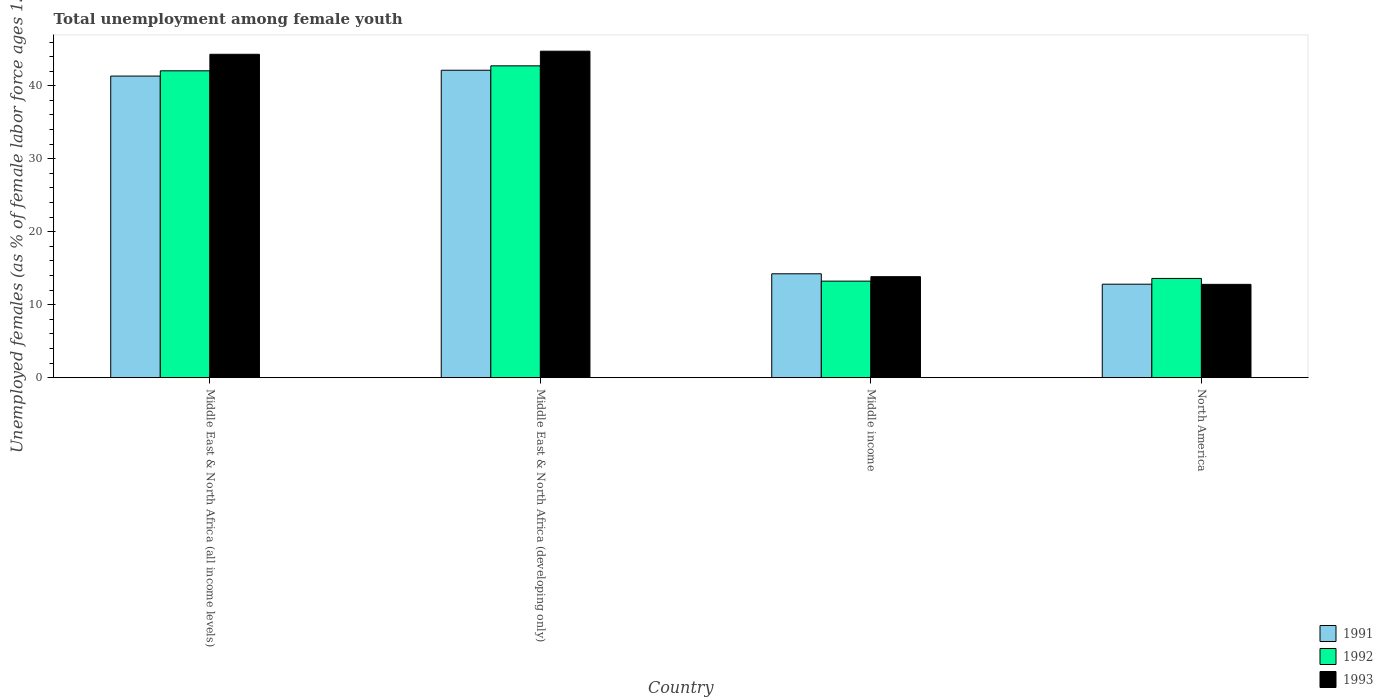Are the number of bars per tick equal to the number of legend labels?
Make the answer very short. Yes. Are the number of bars on each tick of the X-axis equal?
Give a very brief answer. Yes. What is the label of the 2nd group of bars from the left?
Make the answer very short. Middle East & North Africa (developing only). What is the percentage of unemployed females in in 1992 in Middle income?
Your response must be concise. 13.23. Across all countries, what is the maximum percentage of unemployed females in in 1993?
Offer a very short reply. 44.74. Across all countries, what is the minimum percentage of unemployed females in in 1992?
Provide a succinct answer. 13.23. In which country was the percentage of unemployed females in in 1992 maximum?
Provide a succinct answer. Middle East & North Africa (developing only). What is the total percentage of unemployed females in in 1993 in the graph?
Provide a succinct answer. 115.69. What is the difference between the percentage of unemployed females in in 1993 in Middle East & North Africa (all income levels) and that in North America?
Make the answer very short. 31.53. What is the difference between the percentage of unemployed females in in 1993 in Middle East & North Africa (developing only) and the percentage of unemployed females in in 1991 in Middle income?
Provide a succinct answer. 30.51. What is the average percentage of unemployed females in in 1992 per country?
Offer a very short reply. 27.9. What is the difference between the percentage of unemployed females in of/in 1991 and percentage of unemployed females in of/in 1992 in Middle income?
Your answer should be very brief. 1.01. What is the ratio of the percentage of unemployed females in in 1993 in Middle East & North Africa (all income levels) to that in Middle East & North Africa (developing only)?
Keep it short and to the point. 0.99. Is the percentage of unemployed females in in 1991 in Middle East & North Africa (all income levels) less than that in North America?
Provide a short and direct response. No. Is the difference between the percentage of unemployed females in in 1991 in Middle East & North Africa (developing only) and Middle income greater than the difference between the percentage of unemployed females in in 1992 in Middle East & North Africa (developing only) and Middle income?
Give a very brief answer. No. What is the difference between the highest and the second highest percentage of unemployed females in in 1993?
Your response must be concise. 30.9. What is the difference between the highest and the lowest percentage of unemployed females in in 1992?
Make the answer very short. 29.51. Is the sum of the percentage of unemployed females in in 1993 in Middle East & North Africa (all income levels) and Middle income greater than the maximum percentage of unemployed females in in 1991 across all countries?
Ensure brevity in your answer.  Yes. What does the 2nd bar from the right in North America represents?
Offer a very short reply. 1992. Is it the case that in every country, the sum of the percentage of unemployed females in in 1992 and percentage of unemployed females in in 1991 is greater than the percentage of unemployed females in in 1993?
Provide a succinct answer. Yes. How many bars are there?
Provide a short and direct response. 12. Are all the bars in the graph horizontal?
Your answer should be very brief. No. What is the difference between two consecutive major ticks on the Y-axis?
Offer a terse response. 10. Are the values on the major ticks of Y-axis written in scientific E-notation?
Ensure brevity in your answer.  No. Does the graph contain any zero values?
Offer a very short reply. No. Does the graph contain grids?
Give a very brief answer. No. Where does the legend appear in the graph?
Offer a very short reply. Bottom right. How are the legend labels stacked?
Offer a very short reply. Vertical. What is the title of the graph?
Your answer should be compact. Total unemployment among female youth. What is the label or title of the X-axis?
Keep it short and to the point. Country. What is the label or title of the Y-axis?
Keep it short and to the point. Unemployed females (as % of female labor force ages 15-24). What is the Unemployed females (as % of female labor force ages 15-24) of 1991 in Middle East & North Africa (all income levels)?
Your answer should be compact. 41.33. What is the Unemployed females (as % of female labor force ages 15-24) in 1992 in Middle East & North Africa (all income levels)?
Make the answer very short. 42.05. What is the Unemployed females (as % of female labor force ages 15-24) of 1993 in Middle East & North Africa (all income levels)?
Make the answer very short. 44.32. What is the Unemployed females (as % of female labor force ages 15-24) of 1991 in Middle East & North Africa (developing only)?
Make the answer very short. 42.13. What is the Unemployed females (as % of female labor force ages 15-24) in 1992 in Middle East & North Africa (developing only)?
Your response must be concise. 42.73. What is the Unemployed females (as % of female labor force ages 15-24) of 1993 in Middle East & North Africa (developing only)?
Give a very brief answer. 44.74. What is the Unemployed females (as % of female labor force ages 15-24) in 1991 in Middle income?
Make the answer very short. 14.24. What is the Unemployed females (as % of female labor force ages 15-24) in 1992 in Middle income?
Keep it short and to the point. 13.23. What is the Unemployed females (as % of female labor force ages 15-24) in 1993 in Middle income?
Your response must be concise. 13.84. What is the Unemployed females (as % of female labor force ages 15-24) of 1991 in North America?
Keep it short and to the point. 12.81. What is the Unemployed females (as % of female labor force ages 15-24) in 1992 in North America?
Your answer should be compact. 13.6. What is the Unemployed females (as % of female labor force ages 15-24) in 1993 in North America?
Give a very brief answer. 12.79. Across all countries, what is the maximum Unemployed females (as % of female labor force ages 15-24) of 1991?
Provide a short and direct response. 42.13. Across all countries, what is the maximum Unemployed females (as % of female labor force ages 15-24) of 1992?
Your answer should be compact. 42.73. Across all countries, what is the maximum Unemployed females (as % of female labor force ages 15-24) in 1993?
Offer a very short reply. 44.74. Across all countries, what is the minimum Unemployed females (as % of female labor force ages 15-24) of 1991?
Your answer should be very brief. 12.81. Across all countries, what is the minimum Unemployed females (as % of female labor force ages 15-24) of 1992?
Ensure brevity in your answer.  13.23. Across all countries, what is the minimum Unemployed females (as % of female labor force ages 15-24) in 1993?
Offer a very short reply. 12.79. What is the total Unemployed females (as % of female labor force ages 15-24) in 1991 in the graph?
Give a very brief answer. 110.51. What is the total Unemployed females (as % of female labor force ages 15-24) in 1992 in the graph?
Offer a very short reply. 111.62. What is the total Unemployed females (as % of female labor force ages 15-24) in 1993 in the graph?
Offer a very short reply. 115.69. What is the difference between the Unemployed females (as % of female labor force ages 15-24) in 1991 in Middle East & North Africa (all income levels) and that in Middle East & North Africa (developing only)?
Offer a terse response. -0.8. What is the difference between the Unemployed females (as % of female labor force ages 15-24) in 1992 in Middle East & North Africa (all income levels) and that in Middle East & North Africa (developing only)?
Your answer should be very brief. -0.68. What is the difference between the Unemployed females (as % of female labor force ages 15-24) of 1993 in Middle East & North Africa (all income levels) and that in Middle East & North Africa (developing only)?
Your answer should be very brief. -0.42. What is the difference between the Unemployed females (as % of female labor force ages 15-24) in 1991 in Middle East & North Africa (all income levels) and that in Middle income?
Your answer should be compact. 27.1. What is the difference between the Unemployed females (as % of female labor force ages 15-24) of 1992 in Middle East & North Africa (all income levels) and that in Middle income?
Make the answer very short. 28.83. What is the difference between the Unemployed females (as % of female labor force ages 15-24) in 1993 in Middle East & North Africa (all income levels) and that in Middle income?
Offer a very short reply. 30.48. What is the difference between the Unemployed females (as % of female labor force ages 15-24) in 1991 in Middle East & North Africa (all income levels) and that in North America?
Ensure brevity in your answer.  28.52. What is the difference between the Unemployed females (as % of female labor force ages 15-24) in 1992 in Middle East & North Africa (all income levels) and that in North America?
Keep it short and to the point. 28.46. What is the difference between the Unemployed females (as % of female labor force ages 15-24) in 1993 in Middle East & North Africa (all income levels) and that in North America?
Provide a succinct answer. 31.53. What is the difference between the Unemployed females (as % of female labor force ages 15-24) of 1991 in Middle East & North Africa (developing only) and that in Middle income?
Provide a short and direct response. 27.9. What is the difference between the Unemployed females (as % of female labor force ages 15-24) of 1992 in Middle East & North Africa (developing only) and that in Middle income?
Keep it short and to the point. 29.51. What is the difference between the Unemployed females (as % of female labor force ages 15-24) of 1993 in Middle East & North Africa (developing only) and that in Middle income?
Provide a succinct answer. 30.9. What is the difference between the Unemployed females (as % of female labor force ages 15-24) of 1991 in Middle East & North Africa (developing only) and that in North America?
Offer a terse response. 29.32. What is the difference between the Unemployed females (as % of female labor force ages 15-24) in 1992 in Middle East & North Africa (developing only) and that in North America?
Give a very brief answer. 29.13. What is the difference between the Unemployed females (as % of female labor force ages 15-24) in 1993 in Middle East & North Africa (developing only) and that in North America?
Offer a terse response. 31.95. What is the difference between the Unemployed females (as % of female labor force ages 15-24) of 1991 in Middle income and that in North America?
Your answer should be compact. 1.43. What is the difference between the Unemployed females (as % of female labor force ages 15-24) of 1992 in Middle income and that in North America?
Provide a short and direct response. -0.37. What is the difference between the Unemployed females (as % of female labor force ages 15-24) in 1993 in Middle income and that in North America?
Provide a succinct answer. 1.05. What is the difference between the Unemployed females (as % of female labor force ages 15-24) of 1991 in Middle East & North Africa (all income levels) and the Unemployed females (as % of female labor force ages 15-24) of 1992 in Middle East & North Africa (developing only)?
Your answer should be very brief. -1.4. What is the difference between the Unemployed females (as % of female labor force ages 15-24) in 1991 in Middle East & North Africa (all income levels) and the Unemployed females (as % of female labor force ages 15-24) in 1993 in Middle East & North Africa (developing only)?
Keep it short and to the point. -3.41. What is the difference between the Unemployed females (as % of female labor force ages 15-24) in 1992 in Middle East & North Africa (all income levels) and the Unemployed females (as % of female labor force ages 15-24) in 1993 in Middle East & North Africa (developing only)?
Your answer should be very brief. -2.69. What is the difference between the Unemployed females (as % of female labor force ages 15-24) in 1991 in Middle East & North Africa (all income levels) and the Unemployed females (as % of female labor force ages 15-24) in 1992 in Middle income?
Offer a terse response. 28.1. What is the difference between the Unemployed females (as % of female labor force ages 15-24) of 1991 in Middle East & North Africa (all income levels) and the Unemployed females (as % of female labor force ages 15-24) of 1993 in Middle income?
Provide a succinct answer. 27.49. What is the difference between the Unemployed females (as % of female labor force ages 15-24) of 1992 in Middle East & North Africa (all income levels) and the Unemployed females (as % of female labor force ages 15-24) of 1993 in Middle income?
Ensure brevity in your answer.  28.21. What is the difference between the Unemployed females (as % of female labor force ages 15-24) in 1991 in Middle East & North Africa (all income levels) and the Unemployed females (as % of female labor force ages 15-24) in 1992 in North America?
Offer a very short reply. 27.73. What is the difference between the Unemployed females (as % of female labor force ages 15-24) in 1991 in Middle East & North Africa (all income levels) and the Unemployed females (as % of female labor force ages 15-24) in 1993 in North America?
Your answer should be very brief. 28.54. What is the difference between the Unemployed females (as % of female labor force ages 15-24) of 1992 in Middle East & North Africa (all income levels) and the Unemployed females (as % of female labor force ages 15-24) of 1993 in North America?
Offer a very short reply. 29.27. What is the difference between the Unemployed females (as % of female labor force ages 15-24) of 1991 in Middle East & North Africa (developing only) and the Unemployed females (as % of female labor force ages 15-24) of 1992 in Middle income?
Your answer should be very brief. 28.9. What is the difference between the Unemployed females (as % of female labor force ages 15-24) in 1991 in Middle East & North Africa (developing only) and the Unemployed females (as % of female labor force ages 15-24) in 1993 in Middle income?
Give a very brief answer. 28.29. What is the difference between the Unemployed females (as % of female labor force ages 15-24) of 1992 in Middle East & North Africa (developing only) and the Unemployed females (as % of female labor force ages 15-24) of 1993 in Middle income?
Provide a succinct answer. 28.89. What is the difference between the Unemployed females (as % of female labor force ages 15-24) in 1991 in Middle East & North Africa (developing only) and the Unemployed females (as % of female labor force ages 15-24) in 1992 in North America?
Your answer should be very brief. 28.53. What is the difference between the Unemployed females (as % of female labor force ages 15-24) of 1991 in Middle East & North Africa (developing only) and the Unemployed females (as % of female labor force ages 15-24) of 1993 in North America?
Your response must be concise. 29.34. What is the difference between the Unemployed females (as % of female labor force ages 15-24) of 1992 in Middle East & North Africa (developing only) and the Unemployed females (as % of female labor force ages 15-24) of 1993 in North America?
Offer a terse response. 29.95. What is the difference between the Unemployed females (as % of female labor force ages 15-24) in 1991 in Middle income and the Unemployed females (as % of female labor force ages 15-24) in 1992 in North America?
Your response must be concise. 0.64. What is the difference between the Unemployed females (as % of female labor force ages 15-24) in 1991 in Middle income and the Unemployed females (as % of female labor force ages 15-24) in 1993 in North America?
Offer a very short reply. 1.45. What is the difference between the Unemployed females (as % of female labor force ages 15-24) of 1992 in Middle income and the Unemployed females (as % of female labor force ages 15-24) of 1993 in North America?
Offer a terse response. 0.44. What is the average Unemployed females (as % of female labor force ages 15-24) of 1991 per country?
Provide a succinct answer. 27.63. What is the average Unemployed females (as % of female labor force ages 15-24) in 1992 per country?
Offer a very short reply. 27.9. What is the average Unemployed females (as % of female labor force ages 15-24) of 1993 per country?
Your answer should be compact. 28.92. What is the difference between the Unemployed females (as % of female labor force ages 15-24) in 1991 and Unemployed females (as % of female labor force ages 15-24) in 1992 in Middle East & North Africa (all income levels)?
Provide a short and direct response. -0.72. What is the difference between the Unemployed females (as % of female labor force ages 15-24) of 1991 and Unemployed females (as % of female labor force ages 15-24) of 1993 in Middle East & North Africa (all income levels)?
Keep it short and to the point. -2.99. What is the difference between the Unemployed females (as % of female labor force ages 15-24) in 1992 and Unemployed females (as % of female labor force ages 15-24) in 1993 in Middle East & North Africa (all income levels)?
Provide a succinct answer. -2.26. What is the difference between the Unemployed females (as % of female labor force ages 15-24) of 1991 and Unemployed females (as % of female labor force ages 15-24) of 1992 in Middle East & North Africa (developing only)?
Provide a short and direct response. -0.6. What is the difference between the Unemployed females (as % of female labor force ages 15-24) in 1991 and Unemployed females (as % of female labor force ages 15-24) in 1993 in Middle East & North Africa (developing only)?
Provide a succinct answer. -2.61. What is the difference between the Unemployed females (as % of female labor force ages 15-24) of 1992 and Unemployed females (as % of female labor force ages 15-24) of 1993 in Middle East & North Africa (developing only)?
Keep it short and to the point. -2.01. What is the difference between the Unemployed females (as % of female labor force ages 15-24) in 1991 and Unemployed females (as % of female labor force ages 15-24) in 1992 in Middle income?
Give a very brief answer. 1.01. What is the difference between the Unemployed females (as % of female labor force ages 15-24) in 1991 and Unemployed females (as % of female labor force ages 15-24) in 1993 in Middle income?
Offer a terse response. 0.4. What is the difference between the Unemployed females (as % of female labor force ages 15-24) of 1992 and Unemployed females (as % of female labor force ages 15-24) of 1993 in Middle income?
Your response must be concise. -0.61. What is the difference between the Unemployed females (as % of female labor force ages 15-24) of 1991 and Unemployed females (as % of female labor force ages 15-24) of 1992 in North America?
Your answer should be compact. -0.79. What is the difference between the Unemployed females (as % of female labor force ages 15-24) in 1991 and Unemployed females (as % of female labor force ages 15-24) in 1993 in North America?
Your answer should be compact. 0.02. What is the difference between the Unemployed females (as % of female labor force ages 15-24) of 1992 and Unemployed females (as % of female labor force ages 15-24) of 1993 in North America?
Your response must be concise. 0.81. What is the ratio of the Unemployed females (as % of female labor force ages 15-24) in 1991 in Middle East & North Africa (all income levels) to that in Middle East & North Africa (developing only)?
Keep it short and to the point. 0.98. What is the ratio of the Unemployed females (as % of female labor force ages 15-24) in 1992 in Middle East & North Africa (all income levels) to that in Middle East & North Africa (developing only)?
Your answer should be very brief. 0.98. What is the ratio of the Unemployed females (as % of female labor force ages 15-24) in 1993 in Middle East & North Africa (all income levels) to that in Middle East & North Africa (developing only)?
Provide a short and direct response. 0.99. What is the ratio of the Unemployed females (as % of female labor force ages 15-24) of 1991 in Middle East & North Africa (all income levels) to that in Middle income?
Provide a succinct answer. 2.9. What is the ratio of the Unemployed females (as % of female labor force ages 15-24) of 1992 in Middle East & North Africa (all income levels) to that in Middle income?
Make the answer very short. 3.18. What is the ratio of the Unemployed females (as % of female labor force ages 15-24) in 1993 in Middle East & North Africa (all income levels) to that in Middle income?
Your answer should be very brief. 3.2. What is the ratio of the Unemployed females (as % of female labor force ages 15-24) of 1991 in Middle East & North Africa (all income levels) to that in North America?
Offer a terse response. 3.23. What is the ratio of the Unemployed females (as % of female labor force ages 15-24) of 1992 in Middle East & North Africa (all income levels) to that in North America?
Provide a short and direct response. 3.09. What is the ratio of the Unemployed females (as % of female labor force ages 15-24) in 1993 in Middle East & North Africa (all income levels) to that in North America?
Provide a succinct answer. 3.47. What is the ratio of the Unemployed females (as % of female labor force ages 15-24) of 1991 in Middle East & North Africa (developing only) to that in Middle income?
Provide a succinct answer. 2.96. What is the ratio of the Unemployed females (as % of female labor force ages 15-24) in 1992 in Middle East & North Africa (developing only) to that in Middle income?
Offer a terse response. 3.23. What is the ratio of the Unemployed females (as % of female labor force ages 15-24) of 1993 in Middle East & North Africa (developing only) to that in Middle income?
Provide a succinct answer. 3.23. What is the ratio of the Unemployed females (as % of female labor force ages 15-24) of 1991 in Middle East & North Africa (developing only) to that in North America?
Offer a very short reply. 3.29. What is the ratio of the Unemployed females (as % of female labor force ages 15-24) in 1992 in Middle East & North Africa (developing only) to that in North America?
Offer a very short reply. 3.14. What is the ratio of the Unemployed females (as % of female labor force ages 15-24) in 1993 in Middle East & North Africa (developing only) to that in North America?
Offer a terse response. 3.5. What is the ratio of the Unemployed females (as % of female labor force ages 15-24) in 1991 in Middle income to that in North America?
Offer a very short reply. 1.11. What is the ratio of the Unemployed females (as % of female labor force ages 15-24) in 1992 in Middle income to that in North America?
Give a very brief answer. 0.97. What is the ratio of the Unemployed females (as % of female labor force ages 15-24) of 1993 in Middle income to that in North America?
Offer a very short reply. 1.08. What is the difference between the highest and the second highest Unemployed females (as % of female labor force ages 15-24) in 1991?
Your response must be concise. 0.8. What is the difference between the highest and the second highest Unemployed females (as % of female labor force ages 15-24) in 1992?
Offer a terse response. 0.68. What is the difference between the highest and the second highest Unemployed females (as % of female labor force ages 15-24) of 1993?
Provide a succinct answer. 0.42. What is the difference between the highest and the lowest Unemployed females (as % of female labor force ages 15-24) in 1991?
Your answer should be very brief. 29.32. What is the difference between the highest and the lowest Unemployed females (as % of female labor force ages 15-24) of 1992?
Offer a terse response. 29.51. What is the difference between the highest and the lowest Unemployed females (as % of female labor force ages 15-24) of 1993?
Make the answer very short. 31.95. 